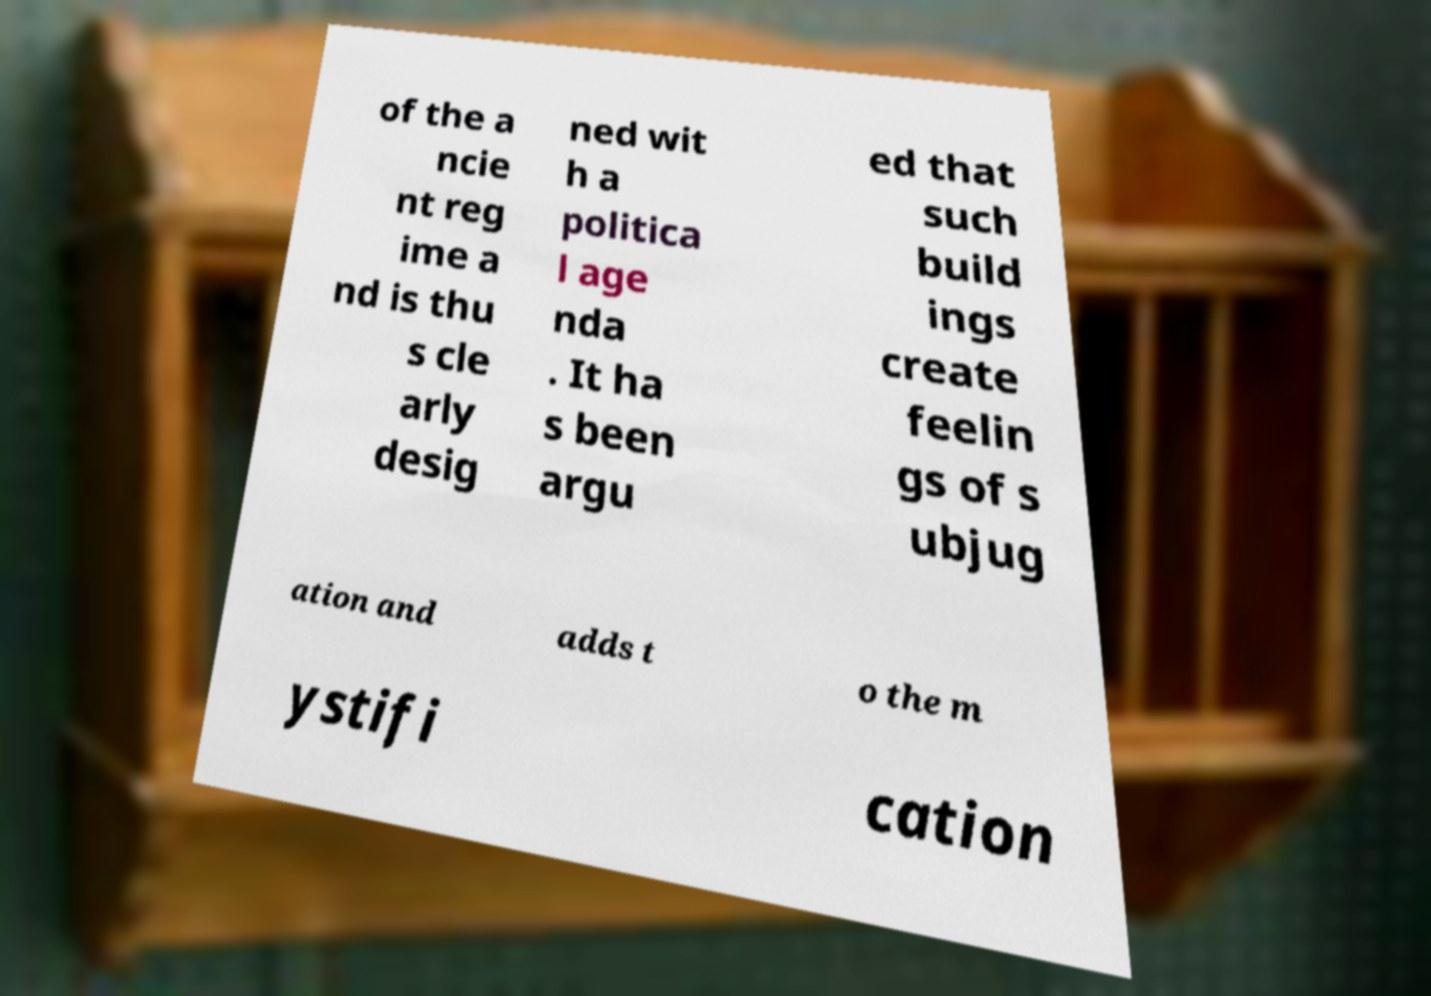I need the written content from this picture converted into text. Can you do that? of the a ncie nt reg ime a nd is thu s cle arly desig ned wit h a politica l age nda . It ha s been argu ed that such build ings create feelin gs of s ubjug ation and adds t o the m ystifi cation 